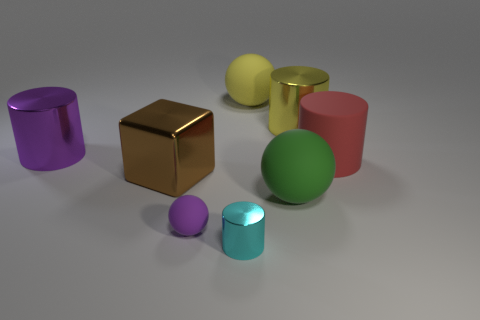Add 1 cylinders. How many objects exist? 9 Subtract all balls. How many objects are left? 5 Subtract 1 yellow spheres. How many objects are left? 7 Subtract all purple shiny cylinders. Subtract all big red objects. How many objects are left? 6 Add 8 tiny purple spheres. How many tiny purple spheres are left? 9 Add 2 small red cylinders. How many small red cylinders exist? 2 